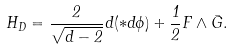<formula> <loc_0><loc_0><loc_500><loc_500>H _ { D } = \frac { 2 } { \sqrt { d - 2 } } d ( \ast d \phi ) + \frac { 1 } { 2 } F \wedge \bar { G } .</formula> 